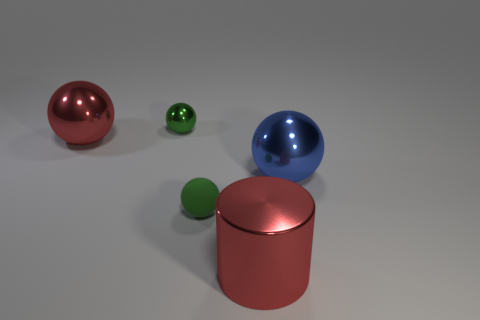Subtract all tiny green shiny spheres. How many spheres are left? 3 Subtract all spheres. How many objects are left? 1 Add 5 small cyan rubber cylinders. How many objects exist? 10 Subtract all green balls. How many balls are left? 2 Subtract 2 balls. How many balls are left? 2 Subtract all purple spheres. Subtract all blue blocks. How many spheres are left? 4 Subtract all brown cubes. How many green spheres are left? 2 Subtract all green rubber spheres. Subtract all rubber things. How many objects are left? 3 Add 4 big red spheres. How many big red spheres are left? 5 Add 2 tiny shiny objects. How many tiny shiny objects exist? 3 